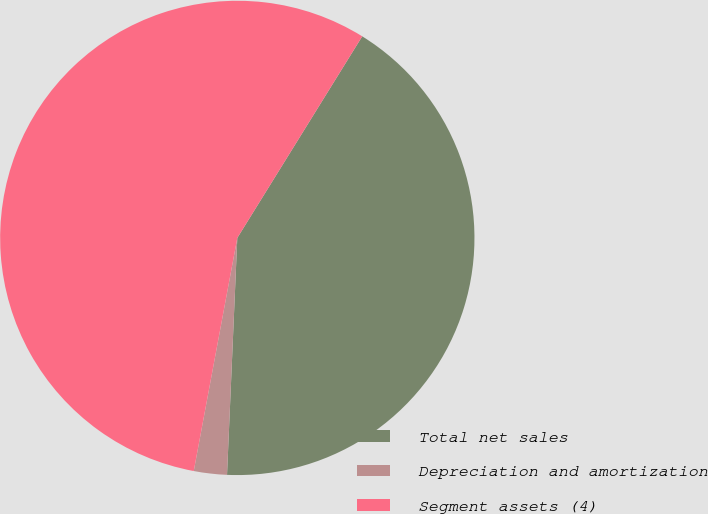Convert chart to OTSL. <chart><loc_0><loc_0><loc_500><loc_500><pie_chart><fcel>Total net sales<fcel>Depreciation and amortization<fcel>Segment assets (4)<nl><fcel>41.86%<fcel>2.25%<fcel>55.89%<nl></chart> 